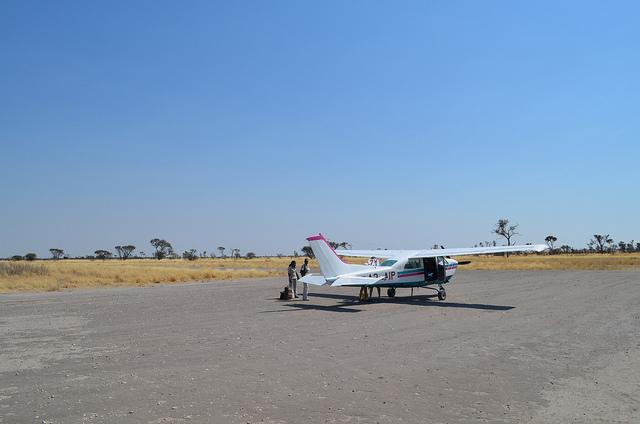What biome is in the background? Please explain your reasoning. savanna. This looks like the savanna in the background. 